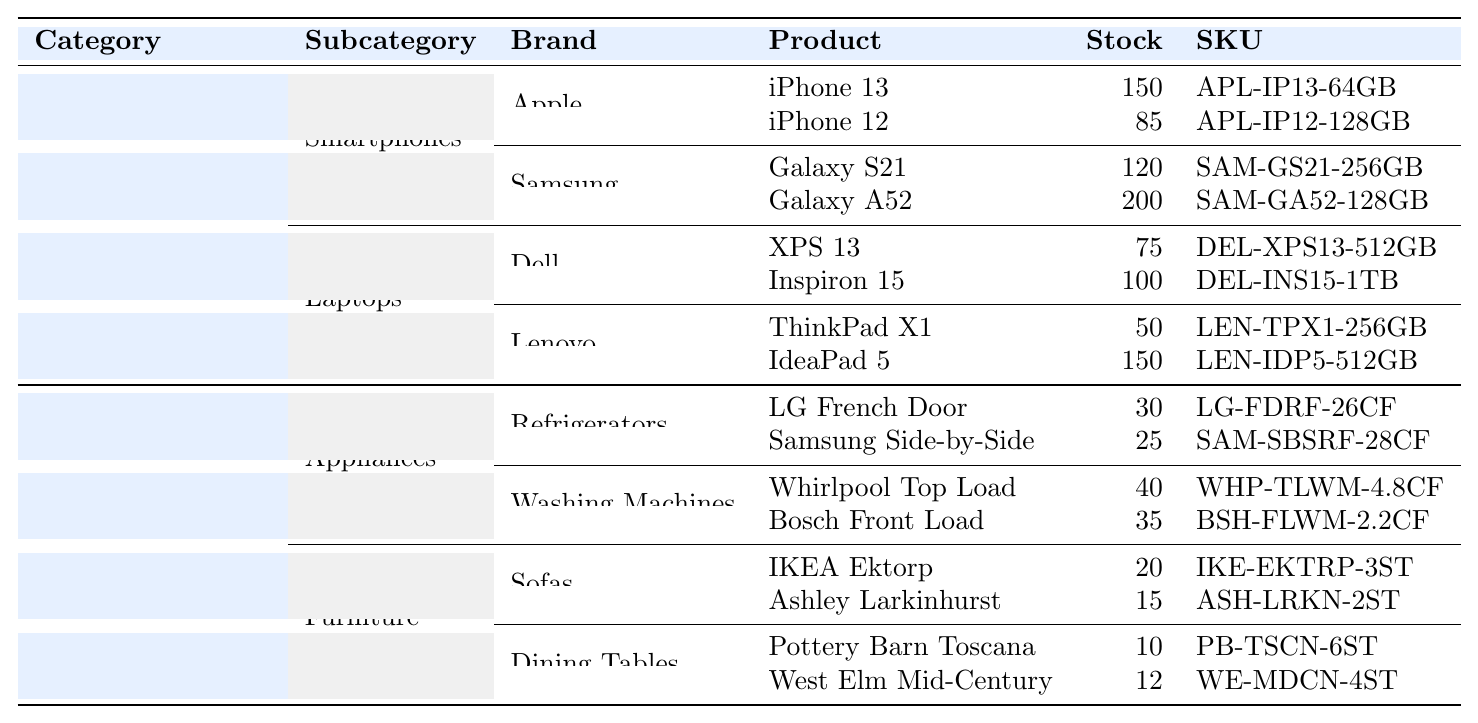What is the stock level of the iPhone 13? The iPhone 13 is listed under the Smartphones category from the Apple brand, and its stock level is directly mentioned as 150.
Answer: 150 How many models of Samsung smartphones are listed? There are two Samsung smartphone models listed: Galaxy S21 and Galaxy A52. Therefore, the count is 2.
Answer: 2 Does LG French Door refrigerator have more stock than Samsung Side-by-Side? The stock for LG French Door is 30 while Samsung Side-by-Side is 25. Since 30 is greater than 25, the answer is Yes.
Answer: Yes What is the total stock of Dell laptops? Dell laptops include XPS 13 with 75 in stock and Inspiron 15 with 100. Adding them gives 75 + 100 = 175.
Answer: 175 Which product has the lowest stock in the table? The product with the lowest stock is Pottery Barn Toscana with only 10 units available.
Answer: Pottery Barn Toscana What is the combined stock of all smartphones listed? The stock levels for smartphones are: iPhone 13 (150), iPhone 12 (85), Galaxy S21 (120), and Galaxy A52 (200). Adding these gives 150 + 85 + 120 + 200 = 555.
Answer: 555 Is there any product from Lenovo that has more than 100 units in stock? The listed Lenovo laptops are ThinkPad X1 with 50 (less than 100) and IdeaPad 5 with 150 (more than 100). This indicates there is at least one product that meets the criteria, so the answer is Yes.
Answer: Yes How many dining tables are listed under the Furniture category? In the Furniture category, there are two dining tables listed: Pottery Barn Toscana and West Elm Mid-Century. Therefore, the count is 2.
Answer: 2 What is the difference in stock between Ashley Larkinhurst sofa and IKEA Ektorp sofa? Ashley Larkinhurst has 15 units, and IKEA Ektorp has 20 units. The difference is 20 - 15 = 5.
Answer: 5 What is the average stock level for refrigerators? The stock for refrigerators are LG French Door with 30 units and Samsung Side-by-Side with 25 units. The average is calculated as (30 + 25) / 2 = 27.5.
Answer: 27.5 